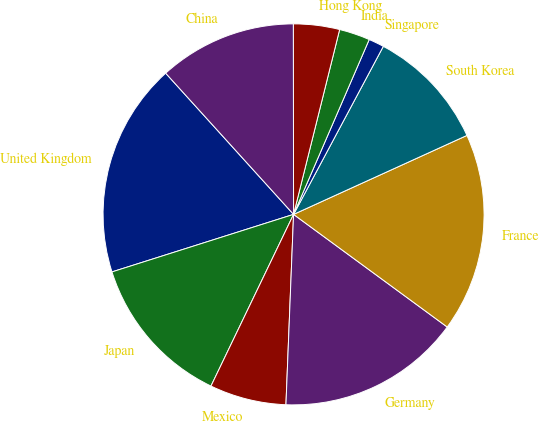Convert chart to OTSL. <chart><loc_0><loc_0><loc_500><loc_500><pie_chart><fcel>United Kingdom<fcel>Japan<fcel>Mexico<fcel>Germany<fcel>France<fcel>South Korea<fcel>Singapore<fcel>India<fcel>Hong Kong<fcel>China<nl><fcel>18.17%<fcel>12.98%<fcel>6.5%<fcel>15.57%<fcel>16.87%<fcel>10.39%<fcel>1.31%<fcel>2.61%<fcel>3.91%<fcel>11.69%<nl></chart> 